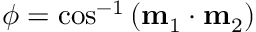Convert formula to latex. <formula><loc_0><loc_0><loc_500><loc_500>\phi = \cos ^ { - 1 } { \left ( m _ { 1 } \cdot m _ { 2 } \right ) }</formula> 